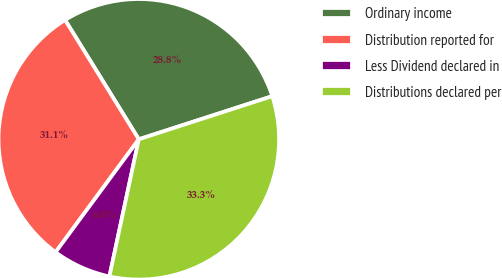Convert chart to OTSL. <chart><loc_0><loc_0><loc_500><loc_500><pie_chart><fcel>Ordinary income<fcel>Distribution reported for<fcel>Less Dividend declared in<fcel>Distributions declared per<nl><fcel>28.83%<fcel>31.08%<fcel>6.75%<fcel>33.33%<nl></chart> 